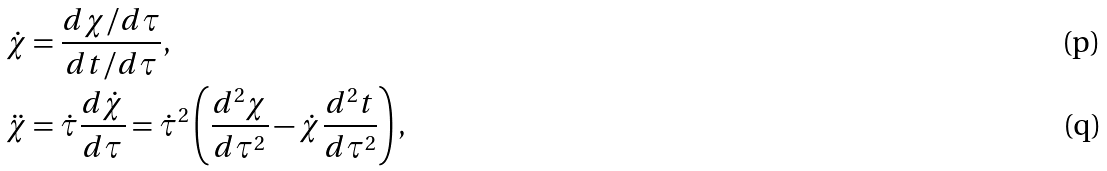<formula> <loc_0><loc_0><loc_500><loc_500>\dot { \chi } & = \frac { d \chi / d \tau } { d t / d \tau } , \\ \ddot { \chi } & = \dot { \tau } \frac { d \dot { \chi } } { d \tau } = \dot { \tau } ^ { 2 } \left ( \frac { d ^ { 2 } \chi } { d \tau ^ { 2 } } - \dot { \chi } \frac { d ^ { 2 } t } { d \tau ^ { 2 } } \right ) ,</formula> 